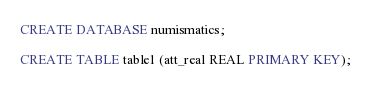Convert code to text. <code><loc_0><loc_0><loc_500><loc_500><_SQL_>
CREATE DATABASE numismatics;

CREATE TABLE table1 (att_real REAL PRIMARY KEY);</code> 